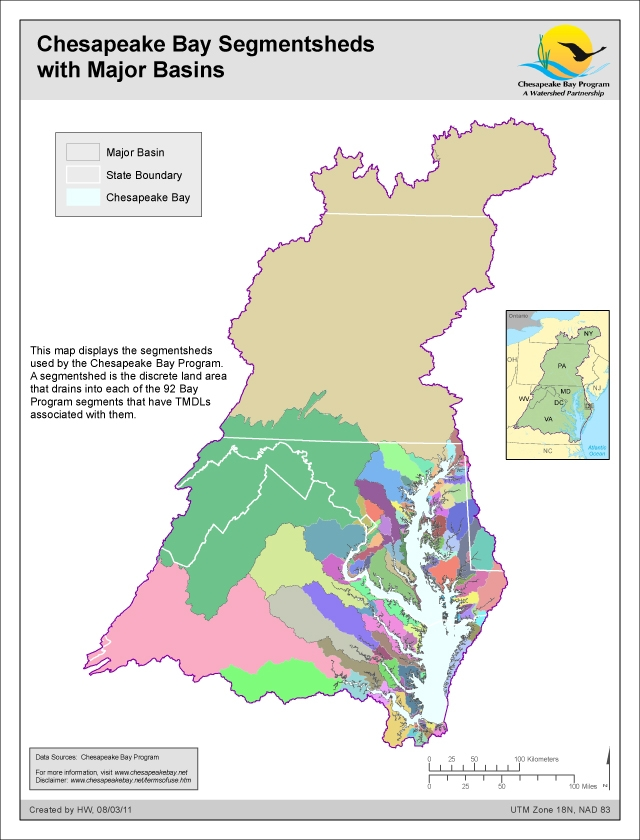How does the segmentshed map correlate with the state boundaries, and what might this indicate about interstate cooperation in managing the Chesapeake Bay's watershed? The segmentshed map distinctly shows various segmentsheds overlaid with state boundaries, highlighted by purple lines. These state boundaries intersect many of the segmentsheds, indicating that the land areas contributing to the Bay’s water quality span across multiple jurisdictions. This geographical reality implies that the Chesapeake Bay's ecological health is a shared responsibility among the states within the watershed. Effective management of the watershed's environmental challenges, such as implementing Total Maximum Daily Loads (TMDLs) for pollutants, requires coordinated interstate efforts. Collaboration among different state governments and agencies under the Chesapeake Bay Program is essential to address these challenges comprehensively, reflecting the critical need for shared strategies and cooperative policies. 